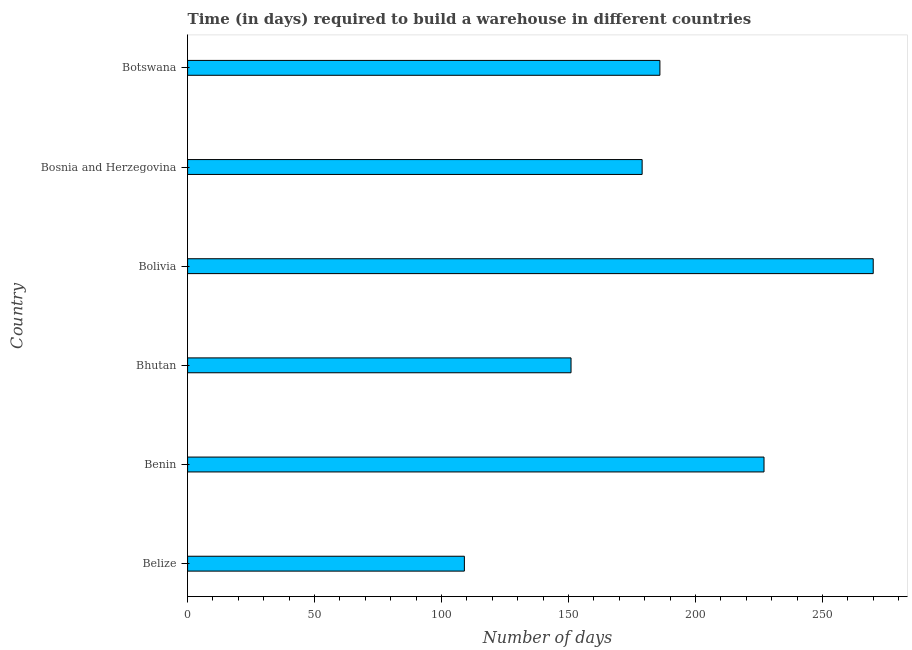Does the graph contain any zero values?
Give a very brief answer. No. What is the title of the graph?
Your answer should be compact. Time (in days) required to build a warehouse in different countries. What is the label or title of the X-axis?
Offer a terse response. Number of days. What is the label or title of the Y-axis?
Ensure brevity in your answer.  Country. What is the time required to build a warehouse in Benin?
Provide a short and direct response. 227. Across all countries, what is the maximum time required to build a warehouse?
Give a very brief answer. 270. Across all countries, what is the minimum time required to build a warehouse?
Make the answer very short. 109. In which country was the time required to build a warehouse maximum?
Offer a terse response. Bolivia. In which country was the time required to build a warehouse minimum?
Keep it short and to the point. Belize. What is the sum of the time required to build a warehouse?
Give a very brief answer. 1122. What is the difference between the time required to build a warehouse in Bolivia and Botswana?
Make the answer very short. 84. What is the average time required to build a warehouse per country?
Your response must be concise. 187. What is the median time required to build a warehouse?
Your response must be concise. 182.5. What is the ratio of the time required to build a warehouse in Bhutan to that in Botswana?
Your response must be concise. 0.81. Is the time required to build a warehouse in Benin less than that in Bosnia and Herzegovina?
Your answer should be compact. No. What is the difference between the highest and the second highest time required to build a warehouse?
Give a very brief answer. 43. Is the sum of the time required to build a warehouse in Benin and Bosnia and Herzegovina greater than the maximum time required to build a warehouse across all countries?
Your answer should be compact. Yes. What is the difference between the highest and the lowest time required to build a warehouse?
Ensure brevity in your answer.  161. How many bars are there?
Your response must be concise. 6. How many countries are there in the graph?
Keep it short and to the point. 6. Are the values on the major ticks of X-axis written in scientific E-notation?
Keep it short and to the point. No. What is the Number of days of Belize?
Give a very brief answer. 109. What is the Number of days of Benin?
Your response must be concise. 227. What is the Number of days in Bhutan?
Offer a very short reply. 151. What is the Number of days in Bolivia?
Provide a succinct answer. 270. What is the Number of days in Bosnia and Herzegovina?
Offer a terse response. 179. What is the Number of days in Botswana?
Give a very brief answer. 186. What is the difference between the Number of days in Belize and Benin?
Offer a very short reply. -118. What is the difference between the Number of days in Belize and Bhutan?
Your answer should be compact. -42. What is the difference between the Number of days in Belize and Bolivia?
Provide a succinct answer. -161. What is the difference between the Number of days in Belize and Bosnia and Herzegovina?
Provide a succinct answer. -70. What is the difference between the Number of days in Belize and Botswana?
Provide a short and direct response. -77. What is the difference between the Number of days in Benin and Bolivia?
Make the answer very short. -43. What is the difference between the Number of days in Benin and Bosnia and Herzegovina?
Your answer should be very brief. 48. What is the difference between the Number of days in Bhutan and Bolivia?
Offer a very short reply. -119. What is the difference between the Number of days in Bhutan and Botswana?
Offer a very short reply. -35. What is the difference between the Number of days in Bolivia and Bosnia and Herzegovina?
Provide a succinct answer. 91. What is the difference between the Number of days in Bolivia and Botswana?
Keep it short and to the point. 84. What is the ratio of the Number of days in Belize to that in Benin?
Offer a terse response. 0.48. What is the ratio of the Number of days in Belize to that in Bhutan?
Make the answer very short. 0.72. What is the ratio of the Number of days in Belize to that in Bolivia?
Ensure brevity in your answer.  0.4. What is the ratio of the Number of days in Belize to that in Bosnia and Herzegovina?
Make the answer very short. 0.61. What is the ratio of the Number of days in Belize to that in Botswana?
Provide a succinct answer. 0.59. What is the ratio of the Number of days in Benin to that in Bhutan?
Give a very brief answer. 1.5. What is the ratio of the Number of days in Benin to that in Bolivia?
Give a very brief answer. 0.84. What is the ratio of the Number of days in Benin to that in Bosnia and Herzegovina?
Keep it short and to the point. 1.27. What is the ratio of the Number of days in Benin to that in Botswana?
Give a very brief answer. 1.22. What is the ratio of the Number of days in Bhutan to that in Bolivia?
Ensure brevity in your answer.  0.56. What is the ratio of the Number of days in Bhutan to that in Bosnia and Herzegovina?
Ensure brevity in your answer.  0.84. What is the ratio of the Number of days in Bhutan to that in Botswana?
Provide a short and direct response. 0.81. What is the ratio of the Number of days in Bolivia to that in Bosnia and Herzegovina?
Your answer should be compact. 1.51. What is the ratio of the Number of days in Bolivia to that in Botswana?
Your answer should be very brief. 1.45. What is the ratio of the Number of days in Bosnia and Herzegovina to that in Botswana?
Make the answer very short. 0.96. 